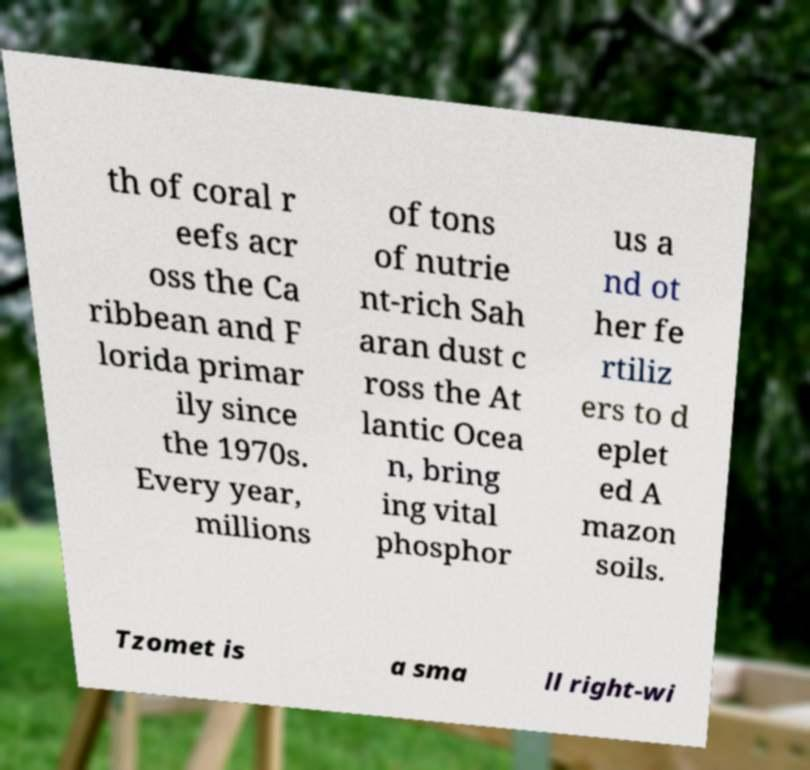There's text embedded in this image that I need extracted. Can you transcribe it verbatim? th of coral r eefs acr oss the Ca ribbean and F lorida primar ily since the 1970s. Every year, millions of tons of nutrie nt-rich Sah aran dust c ross the At lantic Ocea n, bring ing vital phosphor us a nd ot her fe rtiliz ers to d eplet ed A mazon soils. Tzomet is a sma ll right-wi 